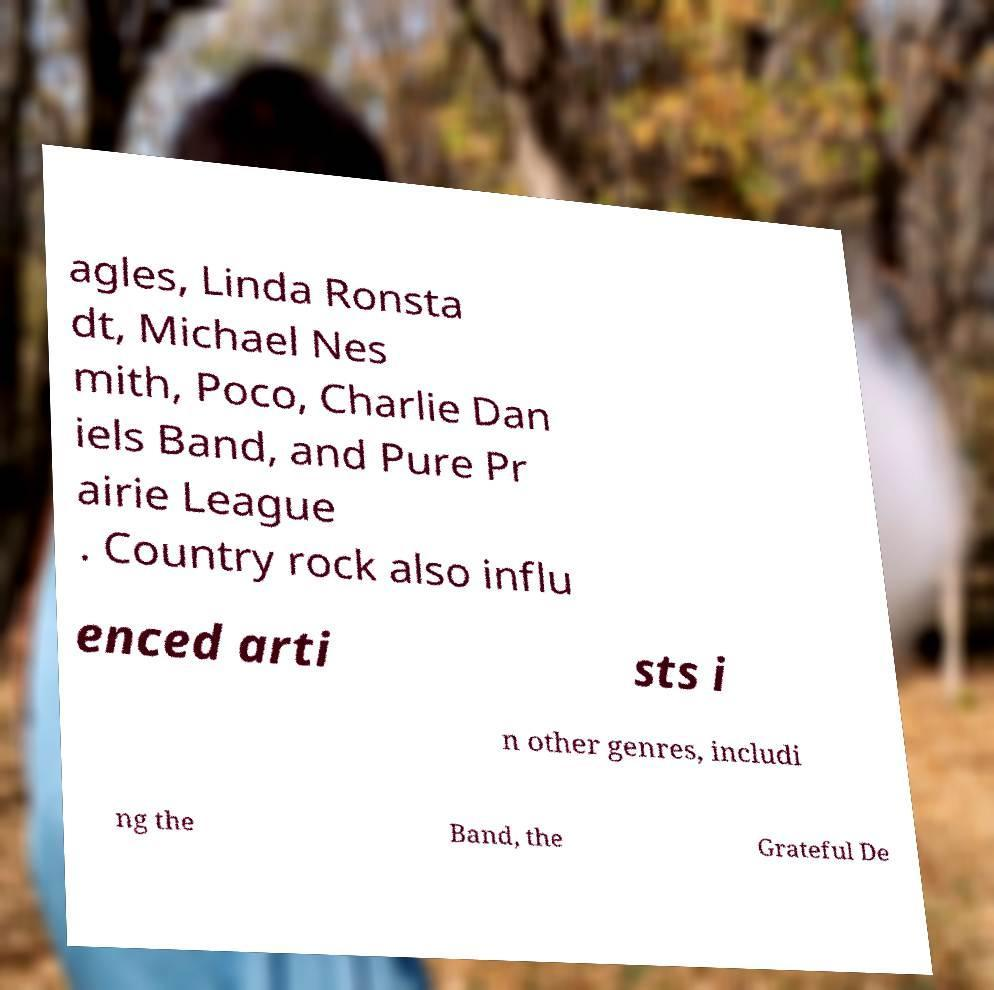What messages or text are displayed in this image? I need them in a readable, typed format. agles, Linda Ronsta dt, Michael Nes mith, Poco, Charlie Dan iels Band, and Pure Pr airie League . Country rock also influ enced arti sts i n other genres, includi ng the Band, the Grateful De 